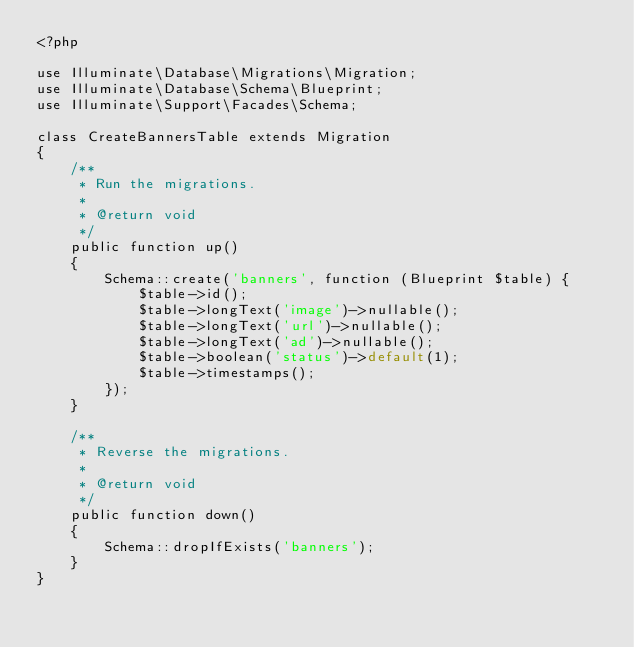Convert code to text. <code><loc_0><loc_0><loc_500><loc_500><_PHP_><?php

use Illuminate\Database\Migrations\Migration;
use Illuminate\Database\Schema\Blueprint;
use Illuminate\Support\Facades\Schema;

class CreateBannersTable extends Migration
{
    /**
     * Run the migrations.
     *
     * @return void
     */
    public function up()
    {
        Schema::create('banners', function (Blueprint $table) {
            $table->id();
            $table->longText('image')->nullable();
            $table->longText('url')->nullable();
            $table->longText('ad')->nullable();
            $table->boolean('status')->default(1);
            $table->timestamps();
        });
    }

    /**
     * Reverse the migrations.
     *
     * @return void
     */
    public function down()
    {
        Schema::dropIfExists('banners');
    }
}
</code> 